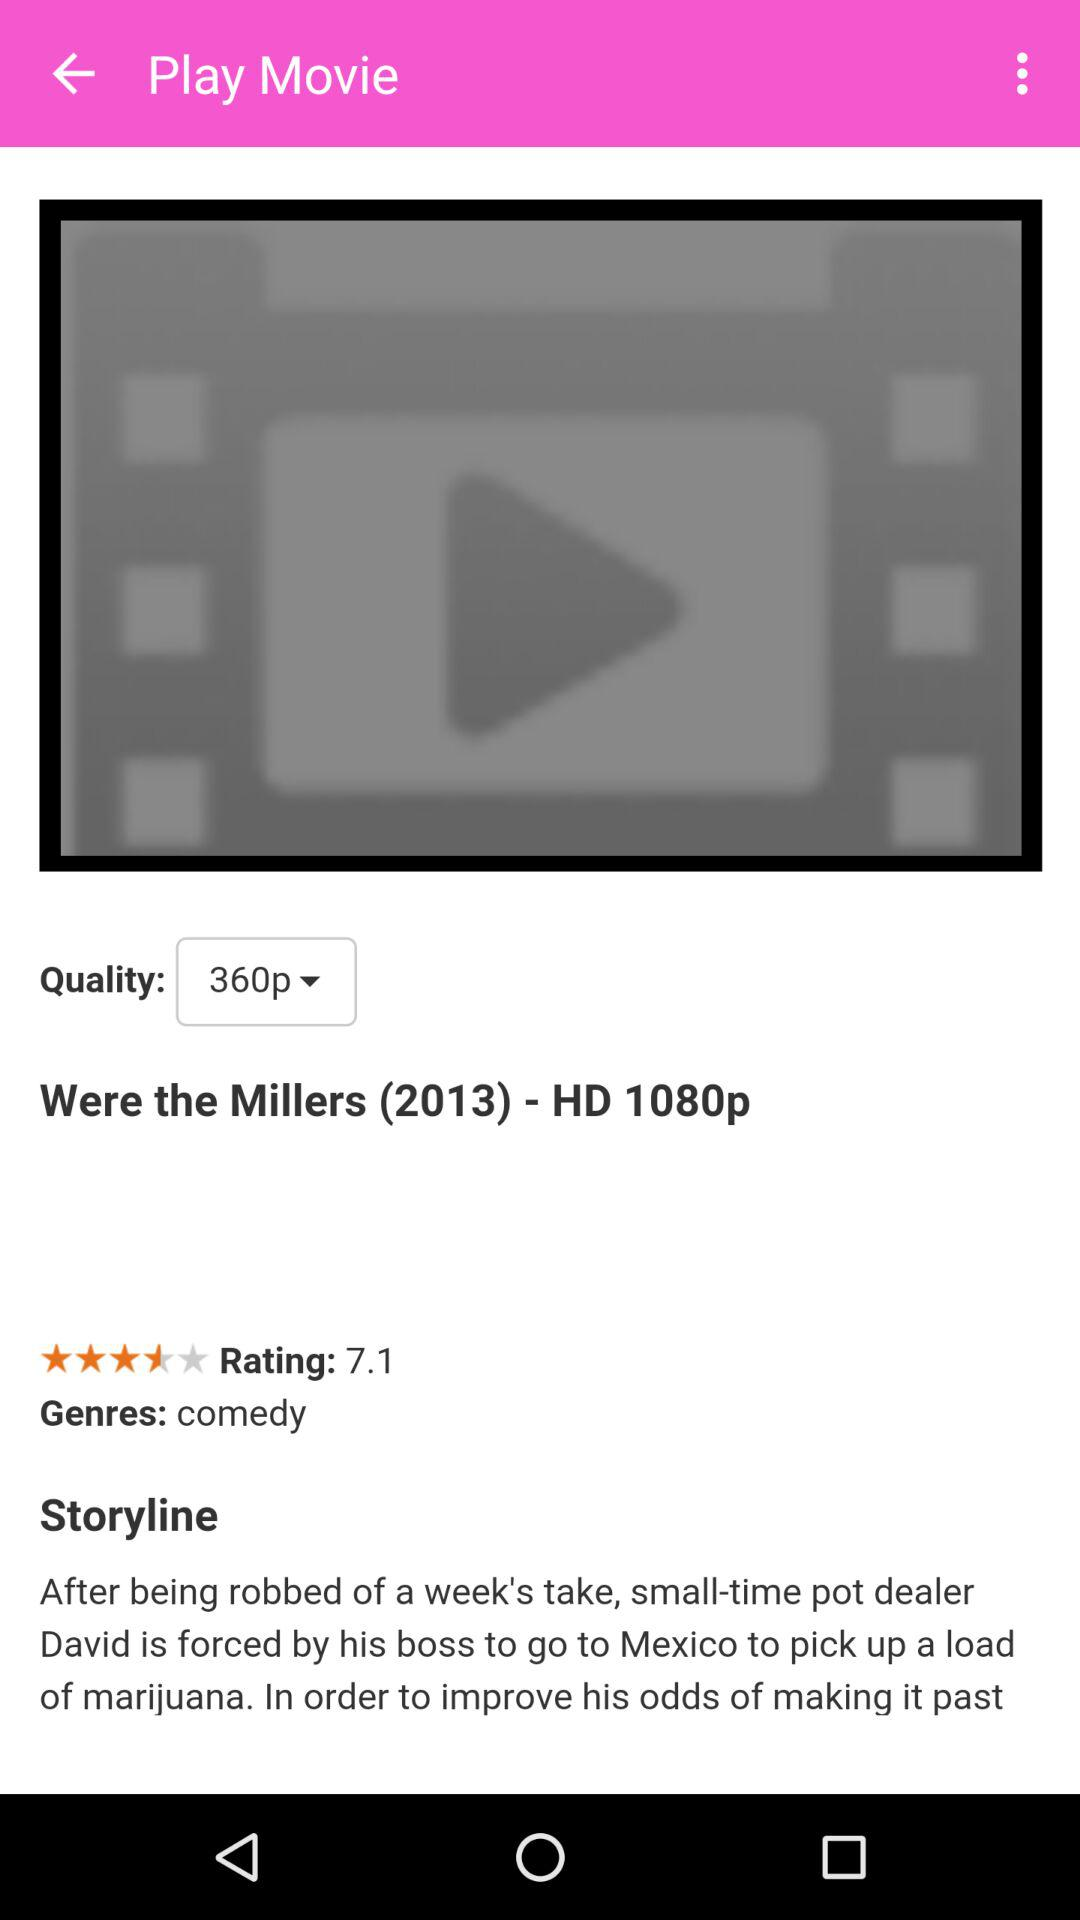What is the rating given to the movie? The rating given to the movie is 7.1. 